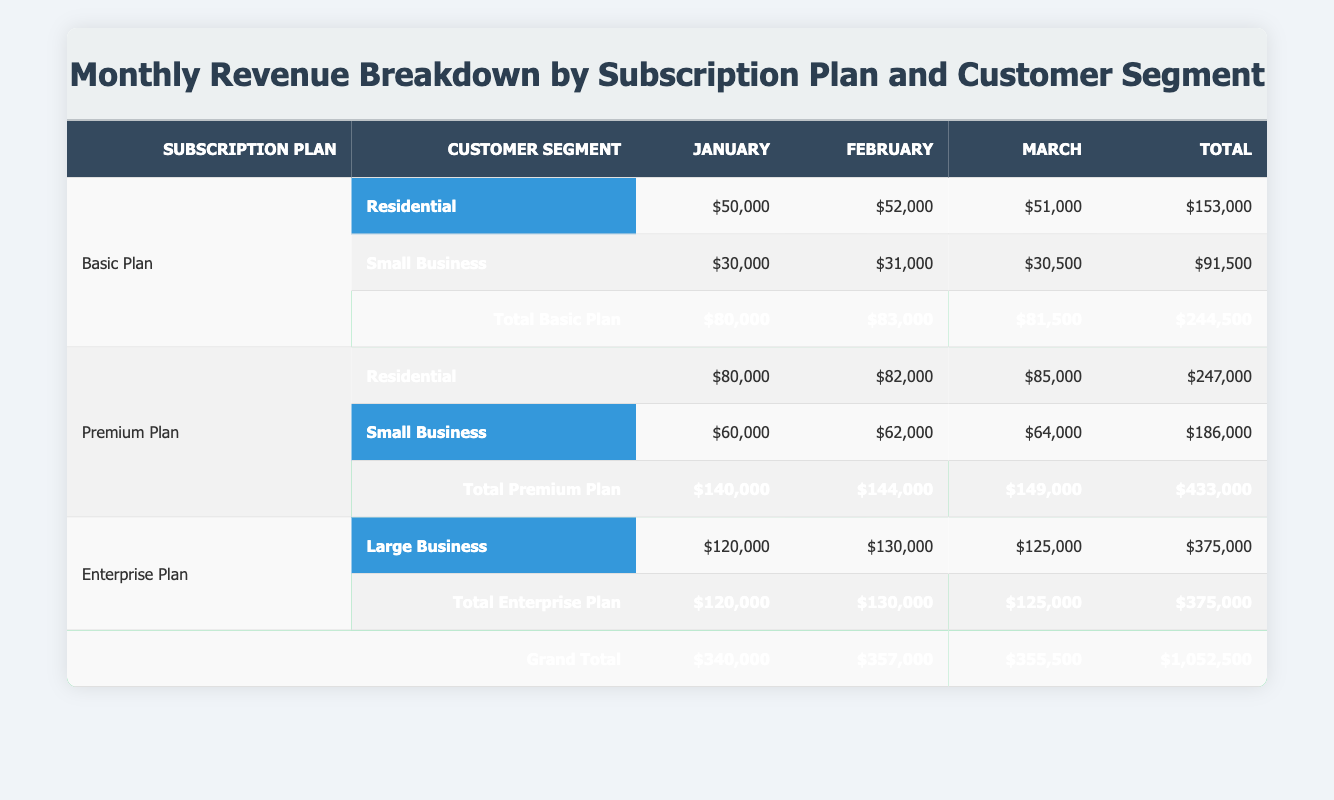What was the total revenue for the Basic Plan in March? The Basic Plan has total revenues for March as follows: Residential $51,000 and Small Business $30,500. Adding these two figures gives us $51,000 + $30,500 = $81,500.
Answer: 81,500 Which customer segment generated the highest revenue in February? For February, the revenue figures for each customer segment are: Residential $82,000, Small Business $62,000, and Large Business $130,000 (from the Enterprise Plan). The highest figure among these is $130,000 from the Large Business segment.
Answer: Large Business What is the total revenue for Premium Plans over the three months? To find the total revenue for Premium Plans, we sum the total values for each month. January is $140,000, February is $144,000, and March is $149,000. The total is $140,000 + $144,000 + $149,000 = $433,000.
Answer: 433,000 Did the revenue from the Small Business segment increase from January to February? In January, the Small Business segment made $30,000 for Basic Plan and $60,000 for Premium Plan, totaling $90,000. In February, the figures are $31,000 for Basic Plan and $62,000 for Premium Plan, which sums up to $93,000. Hence, $93,000 is greater than $90,000, showing an increase.
Answer: Yes What is the difference in total revenue for the Residential segment between January and March? The revenue for the Residential segment in January is $80,000 (Premium Plan) + $50,000 (Basic Plan) = $130,000. For March, it's $85,000 (Premium Plan) + $51,000 (Basic Plan) = $136,000. The difference is $136,000 - $130,000 = $6,000.
Answer: 6,000 What was the total revenue across all plans and segments for the three months? Looking at the grand total row, we add the revenue for January ($340,000), February ($357,000), and March ($355,500). The total is $340,000 + $357,000 + $355,500 = $1,052,500.
Answer: 1,052,500 Is the total revenue from the Enterprise Plan higher than that from the Basic Plan over the three months? The total revenue for the Enterprise Plan is consistent at $375,000 across the three months. For the Basic Plan, the total is $244,500. Since $375,000 is greater than $244,500, the Enterprise Plan revenue is higher.
Answer: Yes Which month had the highest overall revenue from the Basic Plan? From the total revenues for the Basic Plan, we have January at $80,000, February at $83,000, and March at $81,500. The highest is February with $83,000.
Answer: February 